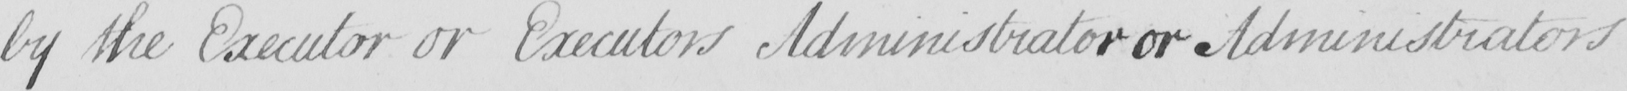What is written in this line of handwriting? by the Executor or Executors Administrator or Administrators 